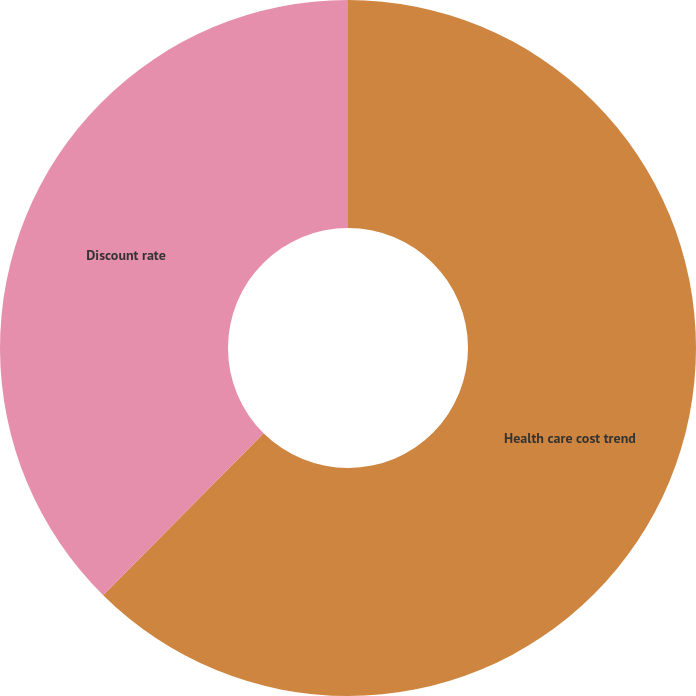<chart> <loc_0><loc_0><loc_500><loc_500><pie_chart><fcel>Health care cost trend<fcel>Discount rate<nl><fcel>62.42%<fcel>37.58%<nl></chart> 